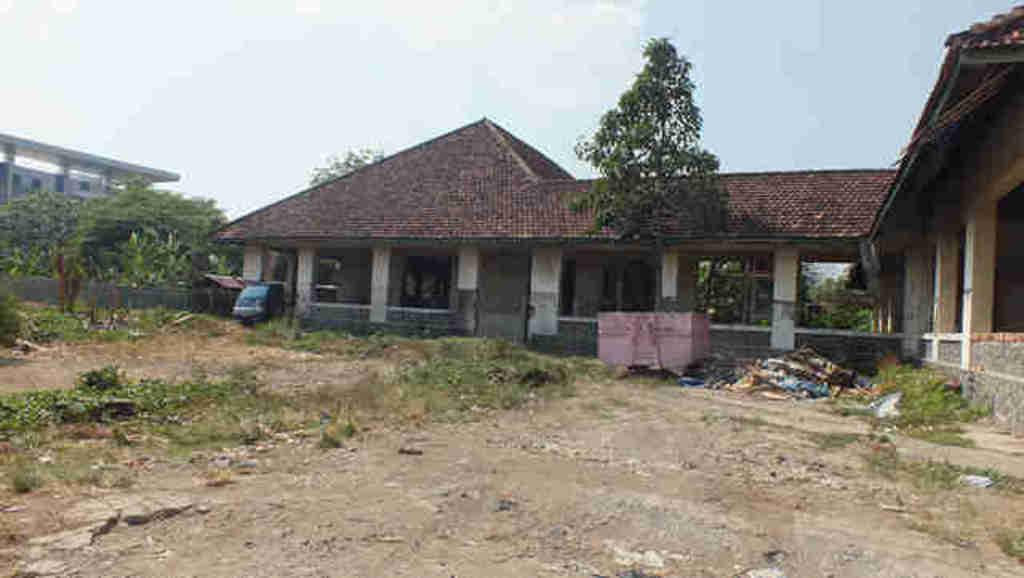What type of vegetation can be seen in the image? There are plants and trees in the image. What type of ground cover is present in the image? There is grass in the image. What type of structures are visible in the image? There are buildings in the image. What part of the natural environment is visible in the image? The sky is visible in the image. What type of table is visible in the image? There is no table present in the image. How does the sky cover the plants in the image? The sky does not cover the plants in the image; it is simply visible in the background. 